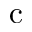Convert formula to latex. <formula><loc_0><loc_0><loc_500><loc_500>c</formula> 